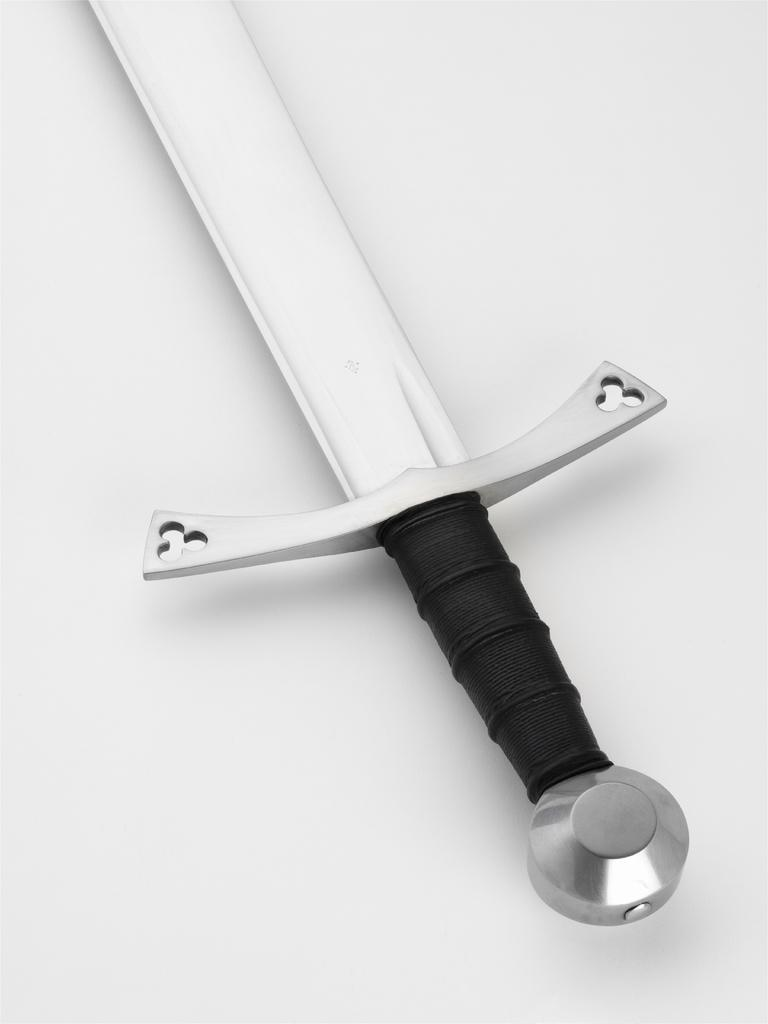What object can be seen in the image? There is a sword in the image. What color is the background of the image? The background of the image is white. What type of plastic button can be seen on the sword in the image? There is no plastic button present on the sword in the image. What kind of cub is visible in the image? There is no cub present in the image. 